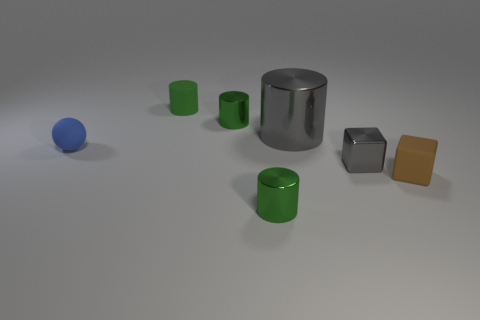How many green cylinders must be subtracted to get 1 green cylinders? 2 Subtract all cyan balls. How many green cylinders are left? 3 Subtract all gray cylinders. How many cylinders are left? 3 Subtract all gray cylinders. How many cylinders are left? 3 Add 3 tiny shiny blocks. How many objects exist? 10 Subtract all cylinders. How many objects are left? 3 Subtract all blue cylinders. Subtract all green spheres. How many cylinders are left? 4 Subtract all tiny matte cylinders. Subtract all large green rubber balls. How many objects are left? 6 Add 6 large gray shiny objects. How many large gray shiny objects are left? 7 Add 5 gray cylinders. How many gray cylinders exist? 6 